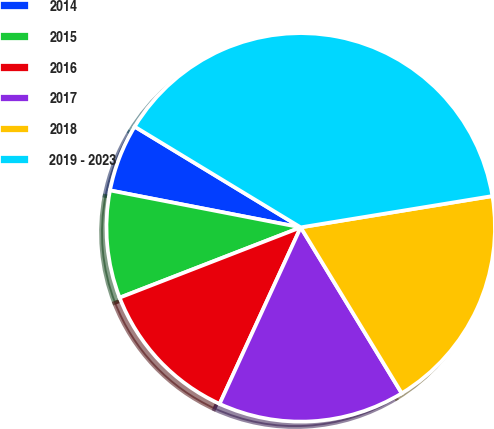Convert chart. <chart><loc_0><loc_0><loc_500><loc_500><pie_chart><fcel>2014<fcel>2015<fcel>2016<fcel>2017<fcel>2018<fcel>2019 - 2023<nl><fcel>5.63%<fcel>8.94%<fcel>12.25%<fcel>15.56%<fcel>18.87%<fcel>38.74%<nl></chart> 